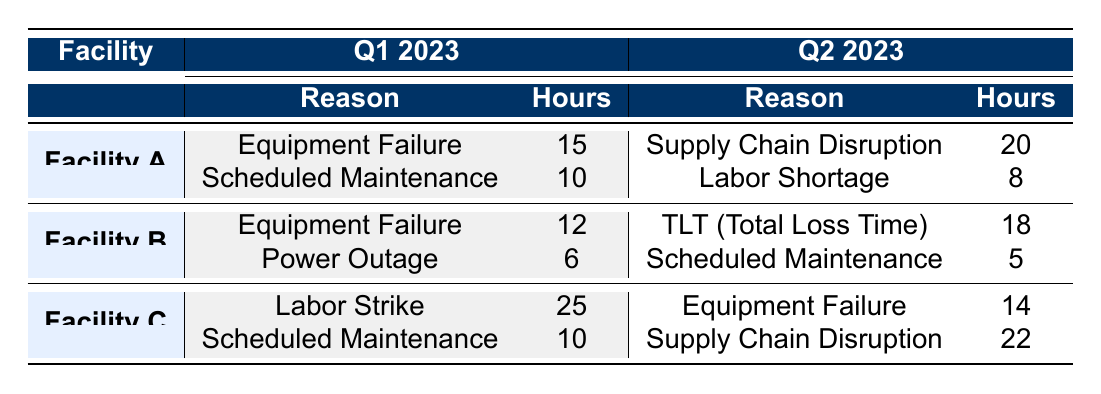What is the total downtime in hours for Facility A in Q1 2023? For Facility A in Q1 2023, the reasons for downtime are Equipment Failure (15 hours) and Scheduled Maintenance (10 hours). Adding these gives us the total: 15 + 10 = 25 hours.
Answer: 25 Which facility experienced the most downtime due to Labor Strike in Q1 2023? Facility C is the only facility listed with a downtime reason of Labor Strike, which totals 25 hours in Q1 2023. Therefore, it experienced the most downtime due to this reason.
Answer: Yes What is the sum of the downtime hours for all facilities in Q2 2023? For Q2 2023, the downtime hours are as follows: Facility A (Supply Chain Disruption: 20 + Labor Shortage: 8 = 28), Facility B (TLT: 18 + Scheduled Maintenance: 5 = 23), and Facility C (Equipment Failure: 14 + Supply Chain Disruption: 22 = 36). Summing these gives 28 + 23 + 36 = 87 hours total for Q2 2023.
Answer: 87 Did any facility have downtime due to Power Outage in Q2 2023? Reviewing the table, Facility B had downtime due to Power Outage in Q1 2023, but there is no mention of Power Outage as a downtime reason in Q2 2023 for any facility.
Answer: No What is the average downtime due to Scheduled Maintenance across all facilities in Q1 2023? For Q1 2023, the downtime hours due to Scheduled Maintenance are: Facility A (10 hours) and Facility C (10 hours), totaling 10 + 10 = 20 hours. Since there are 2 entries, the average is 20 / 2 = 10 hours.
Answer: 10 